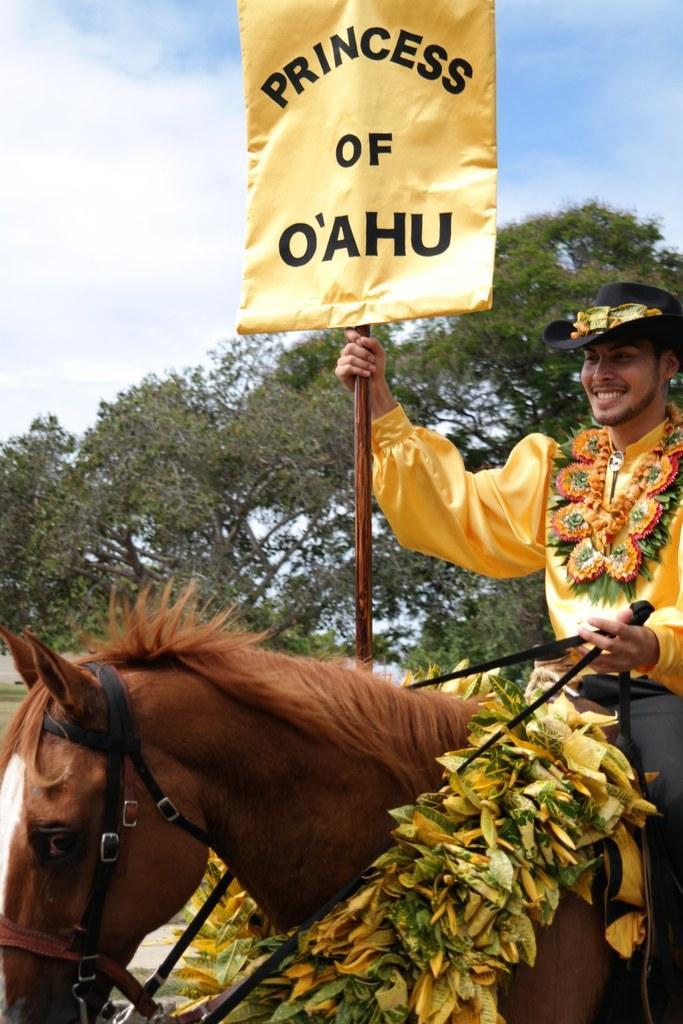In one or two sentences, can you explain what this image depicts? In the image there is a person in yellow dress riding horse with a garland to it and holding a banner , in the back there is a tree and above its sky with clouds. 